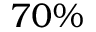Convert formula to latex. <formula><loc_0><loc_0><loc_500><loc_500>7 0 \%</formula> 